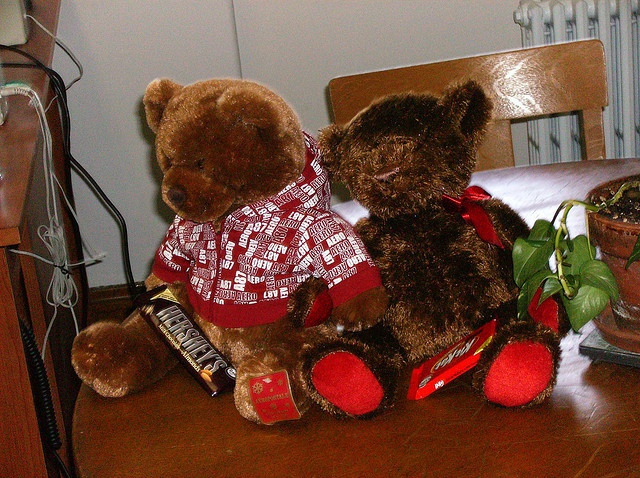Describe the objects in this image and their specific colors. I can see teddy bear in gray, maroon, black, and brown tones, teddy bear in gray, black, maroon, red, and brown tones, dining table in gray, maroon, black, and lavender tones, chair in gray, black, and maroon tones, and chair in gray, brown, maroon, and olive tones in this image. 